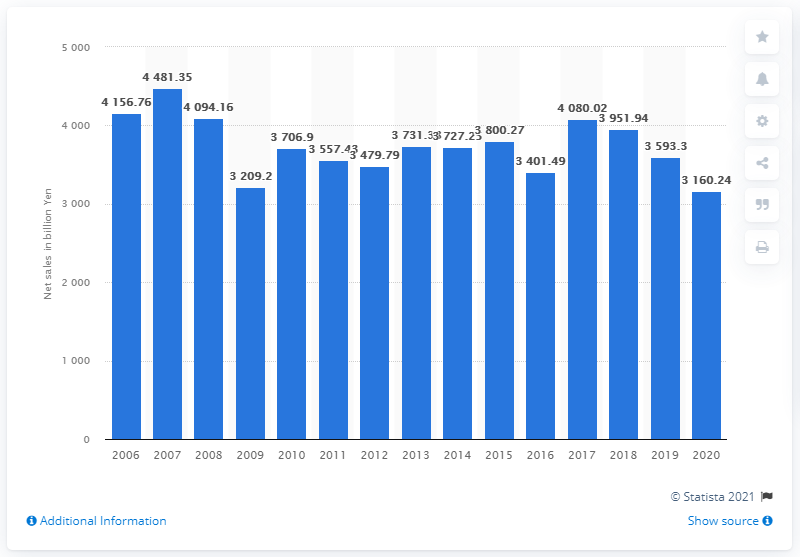List a handful of essential elements in this visual. Canon's net sales in Japanese Yen for the year 2020 were 3160.24. 